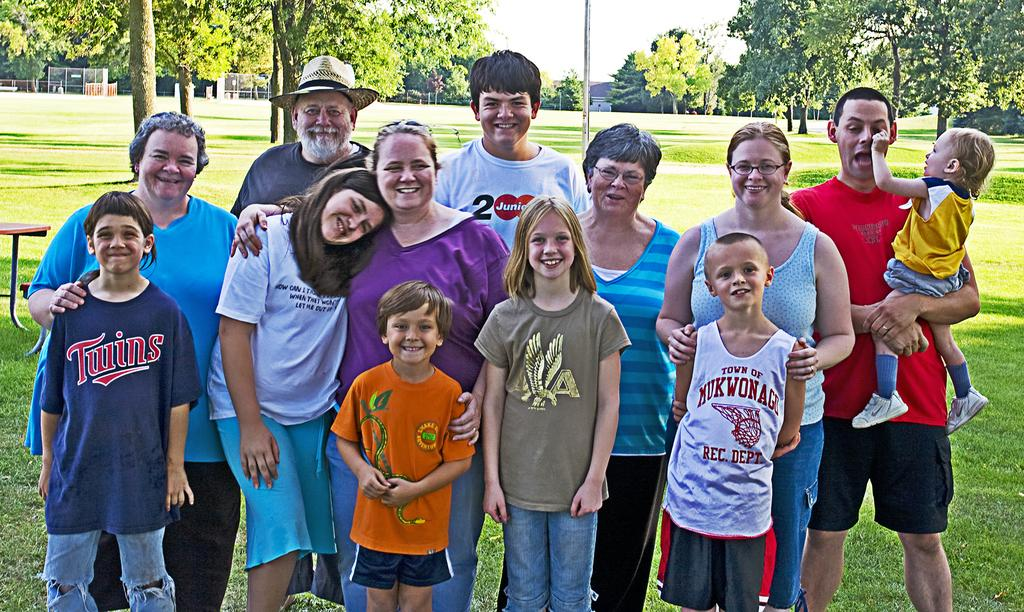How many people are present in the image? There are many people standing in the image. What are the people wearing? The people are wearing clothes. What type of natural environment is visible in the image? There is grass visible in the image. What type of furniture can be seen in the image? There is a table in the image. What type of vegetation is present in the image? There are trees in the image. What type of structure is visible in the image? There is a building in the image. What part of the sky is visible in the image? The sky is visible in the image. What type of accessory can be seen in the image? There is a hat in the image. What type of eyewear is present in the image? There are spectacles in the image. What type of root can be seen growing from the hat in the image? There is no root growing from the hat in the image; it is a hat without any roots. 